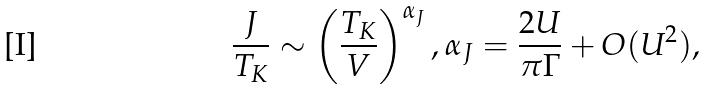Convert formula to latex. <formula><loc_0><loc_0><loc_500><loc_500>\frac { J } { T _ { K } } \sim \left ( \frac { T _ { K } } { V } \right ) ^ { \alpha _ { J } } , \alpha _ { J } = \frac { 2 U } { \pi \Gamma } + O ( U ^ { 2 } ) ,</formula> 